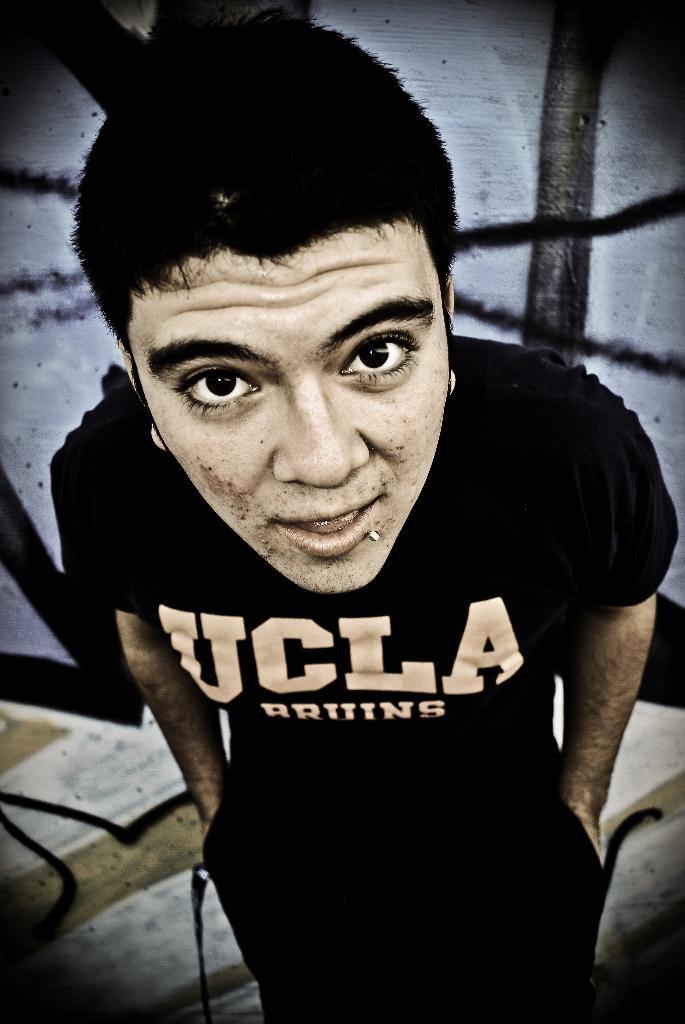What is present in the image? There is a man in the image. What is the man wearing? The man is wearing a black t-shirt. What direction is the building facing in the image? There is no building present in the image. Is the poison visible in the image? There is no poison present in the image. 